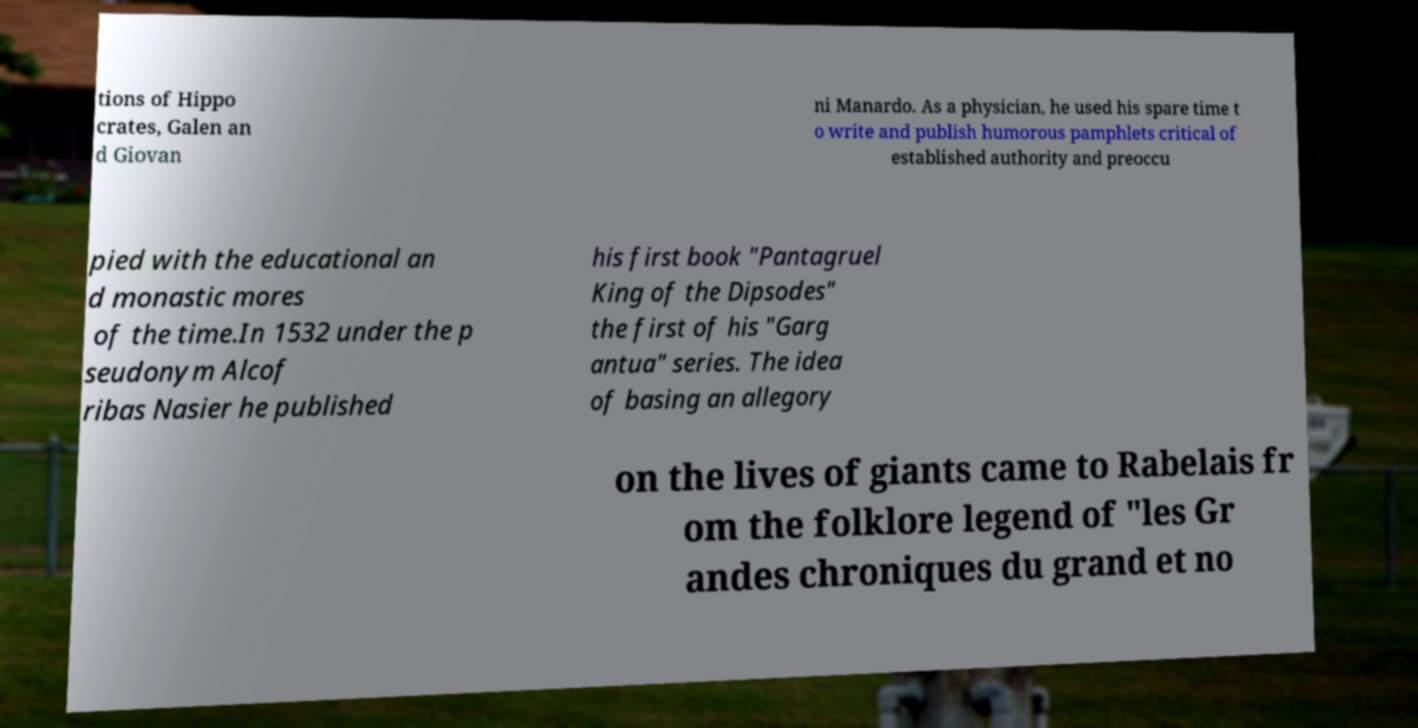Can you accurately transcribe the text from the provided image for me? tions of Hippo crates, Galen an d Giovan ni Manardo. As a physician, he used his spare time t o write and publish humorous pamphlets critical of established authority and preoccu pied with the educational an d monastic mores of the time.In 1532 under the p seudonym Alcof ribas Nasier he published his first book "Pantagruel King of the Dipsodes" the first of his "Garg antua" series. The idea of basing an allegory on the lives of giants came to Rabelais fr om the folklore legend of "les Gr andes chroniques du grand et no 